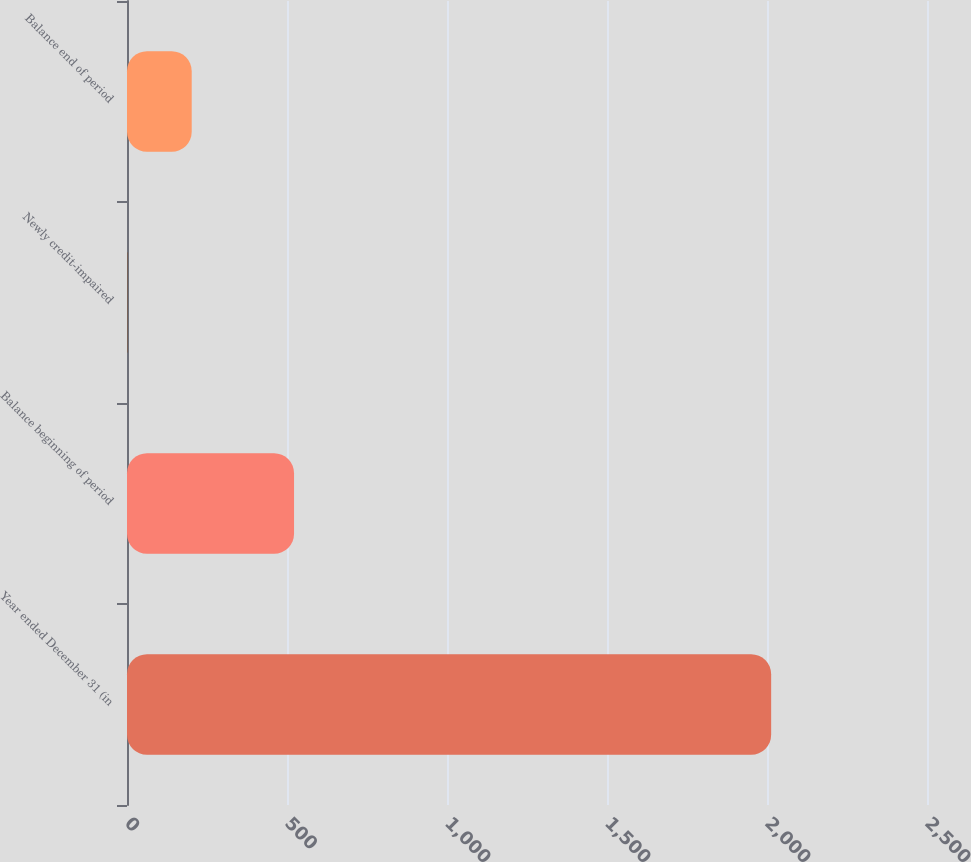Convert chart. <chart><loc_0><loc_0><loc_500><loc_500><bar_chart><fcel>Year ended December 31 (in<fcel>Balance beginning of period<fcel>Newly credit-impaired<fcel>Balance end of period<nl><fcel>2013<fcel>522<fcel>1<fcel>202.2<nl></chart> 